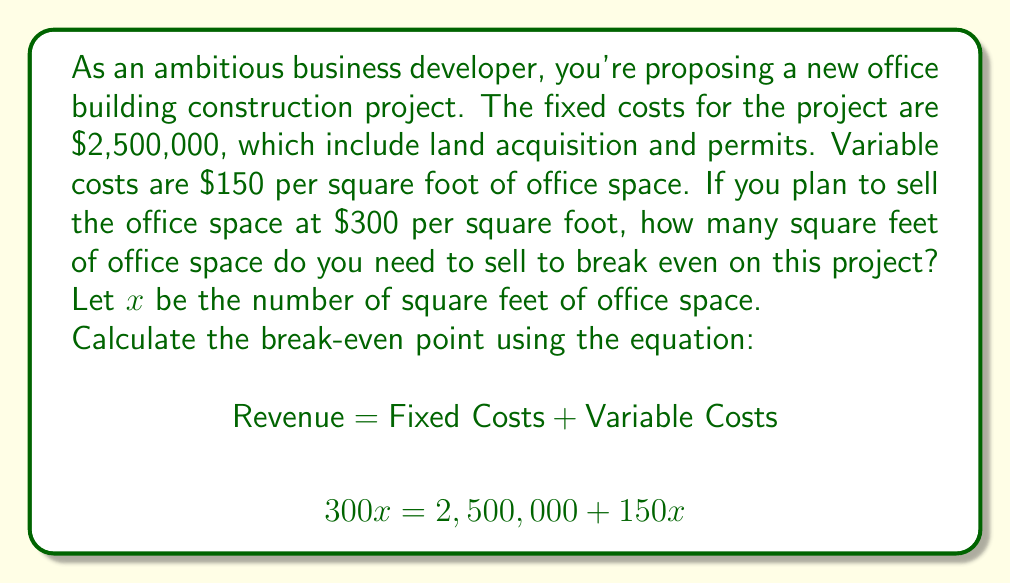Can you solve this math problem? To solve this problem, we'll use the break-even formula:

$$\text{Revenue} = \text{Fixed Costs} + \text{Variable Costs}$$

Let's substitute the given values:

$$300x = 2,500,000 + 150x$$

Now, let's solve for $x$:

1) First, subtract $150x$ from both sides:
   $$300x - 150x = 2,500,000 + 150x - 150x$$
   $$150x = 2,500,000$$

2) Now, divide both sides by 150:
   $$\frac{150x}{150} = \frac{2,500,000}{150}$$
   $$x = 16,666.67$$

Since we can't sell a fraction of a square foot, we need to round up to the nearest whole number.

Therefore, you need to sell 16,667 square feet of office space to break even.

To verify:
- Revenue: $300 \times 16,667 = 5,000,100$
- Costs: $2,500,000 + (150 \times 16,667) = 5,000,050$

The slight difference is due to rounding, but this confirms the break-even point.
Answer: 16,667 square feet 